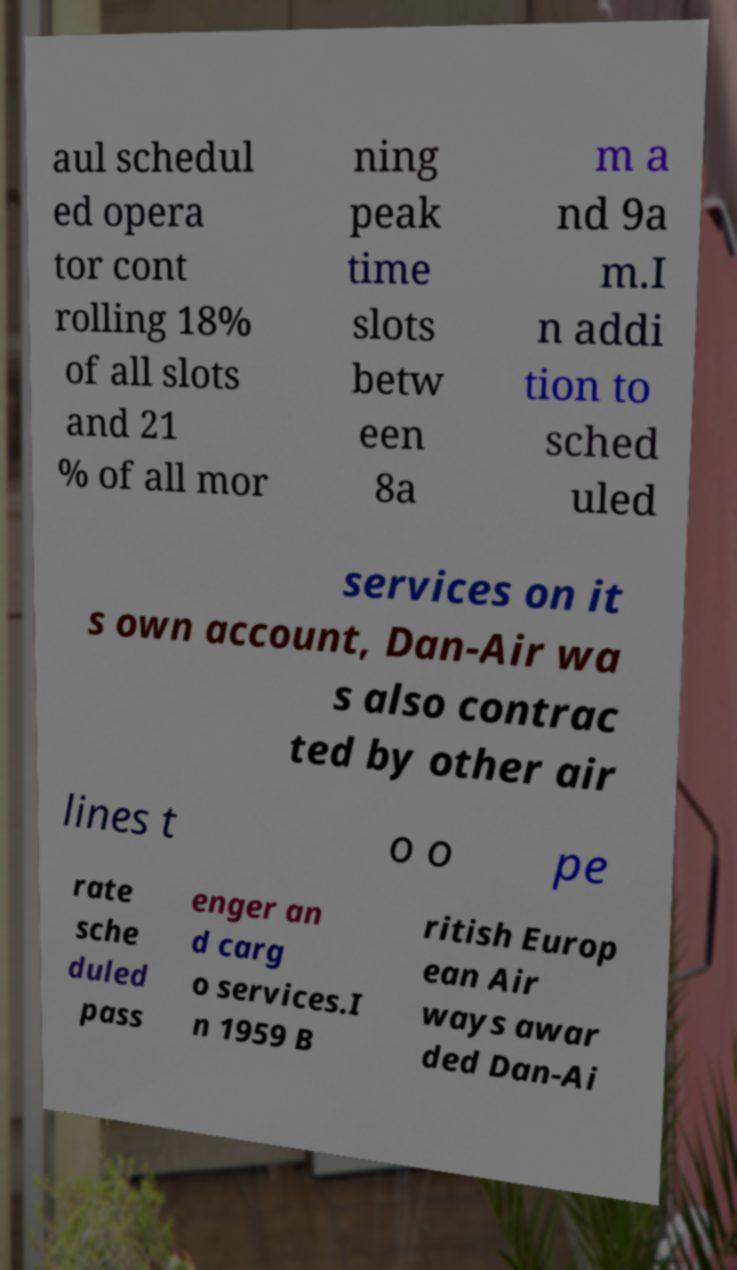I need the written content from this picture converted into text. Can you do that? aul schedul ed opera tor cont rolling 18% of all slots and 21 % of all mor ning peak time slots betw een 8a m a nd 9a m.I n addi tion to sched uled services on it s own account, Dan-Air wa s also contrac ted by other air lines t o o pe rate sche duled pass enger an d carg o services.I n 1959 B ritish Europ ean Air ways awar ded Dan-Ai 